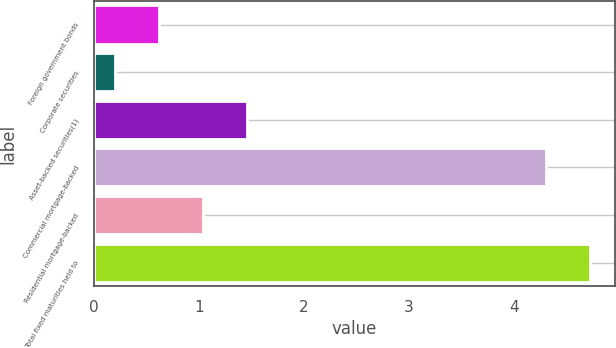Convert chart. <chart><loc_0><loc_0><loc_500><loc_500><bar_chart><fcel>Foreign government bonds<fcel>Corporate securities<fcel>Asset-backed securities(1)<fcel>Commercial mortgage-backed<fcel>Residential mortgage-backed<fcel>Total fixed maturities held to<nl><fcel>0.62<fcel>0.2<fcel>1.46<fcel>4.3<fcel>1.04<fcel>4.72<nl></chart> 